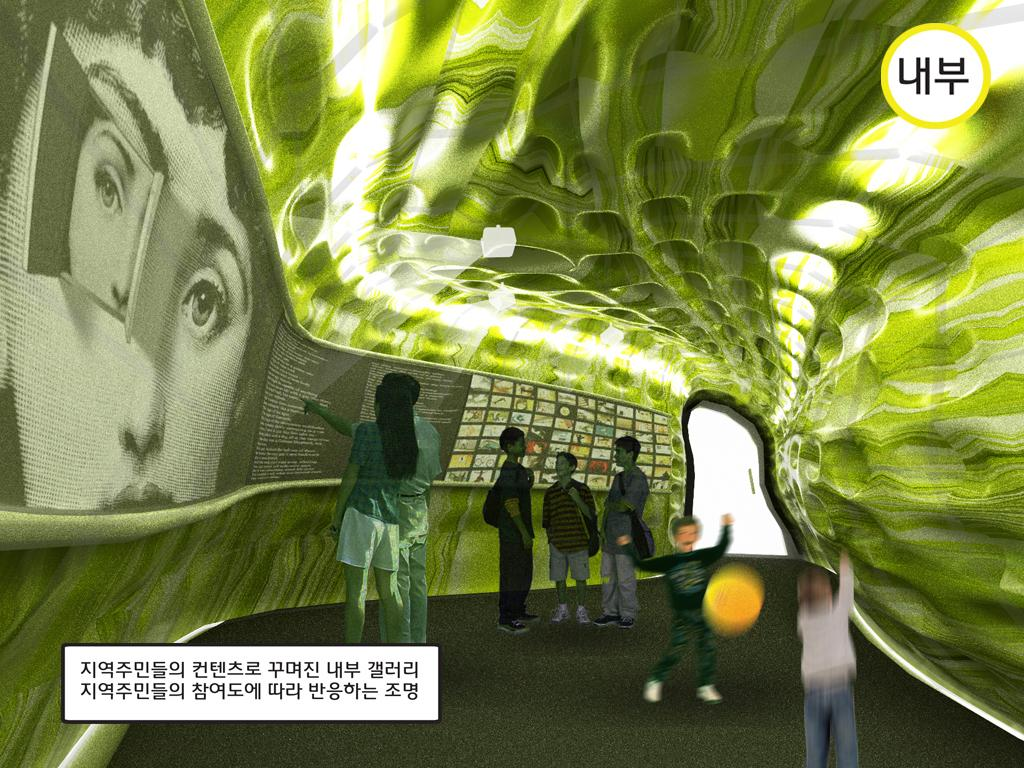How many people are in the image? There is a group of people in the image, but the exact number cannot be determined from the provided facts. What is in front of the people in the image? There is a board in front of the people in the image. What can be seen at the top of the image? There are lights at the top of the image. Is there any indication of the image's origin or ownership? Yes, there is a watermark on the image. Can you see any fairies flying around the people in the image? No, there are no fairies visible in the image. What type of power source is used to light up the lights at the top of the image? The provided facts do not mention any information about the power source for the lights. Is there a kite visible in the image? A: No, there is no kite present in the image. 